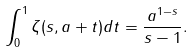<formula> <loc_0><loc_0><loc_500><loc_500>\int _ { 0 } ^ { 1 } \zeta ( s , a + t ) d t = \frac { a ^ { 1 - s } } { s - 1 } .</formula> 